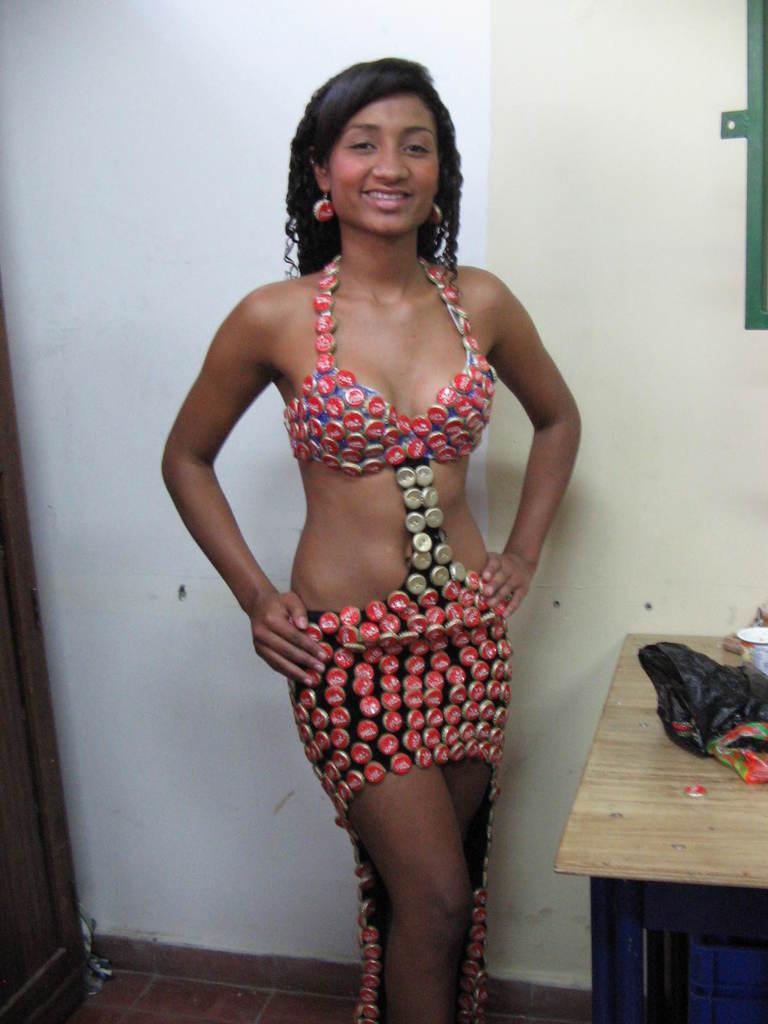Could you give a brief overview of what you see in this image? Image consists of women who is standing ,she is also wearing earrings with a smile on her face. There is a table on the right side corner beside that women, there is a cover and glass on that table. 